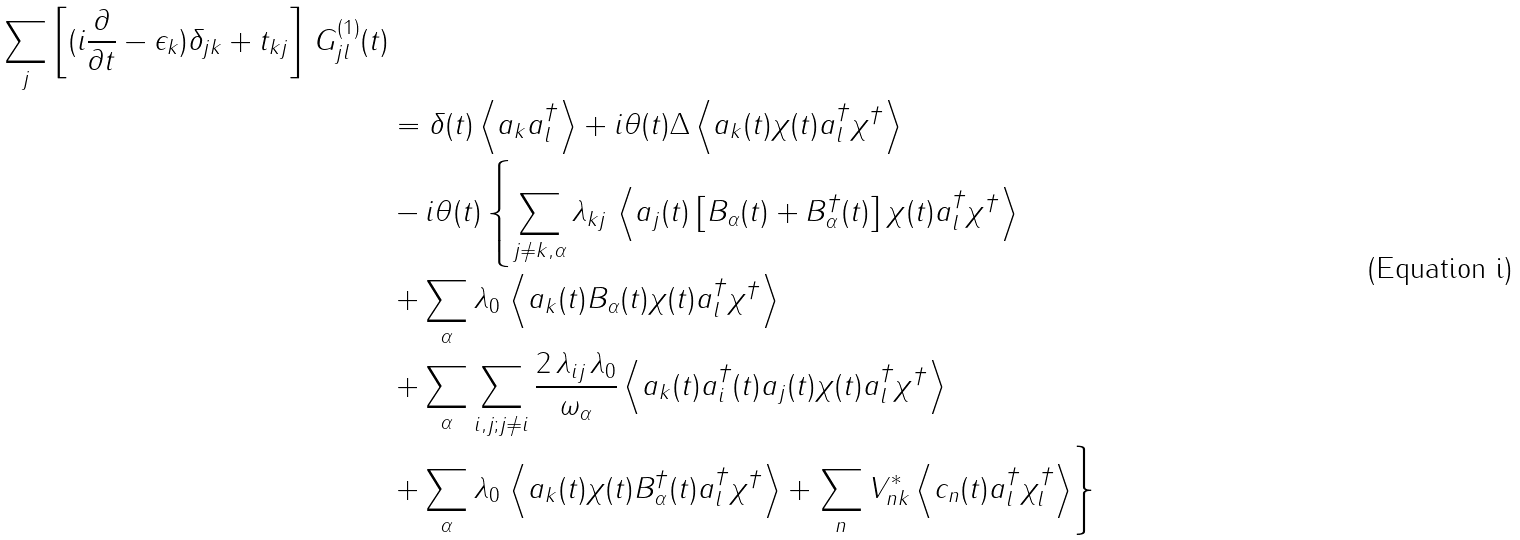Convert formula to latex. <formula><loc_0><loc_0><loc_500><loc_500>{ \sum _ { j } \left [ ( i \frac { \partial } { \partial t } - \epsilon _ { k } ) \delta _ { j k } + t _ { k j } \right ] \, G _ { j l } ^ { ( 1 ) } ( t ) } \\ & = \delta ( t ) \left \langle a _ { k } a _ { l } ^ { \dagger } \right \rangle + i \theta ( t ) \Delta \left \langle a _ { k } ( t ) \chi ( t ) a _ { l } ^ { \dagger } \chi ^ { \dagger } \right \rangle \\ & - i \theta ( t ) \left \{ \sum _ { j \neq k , \alpha } \lambda _ { k j } \, \left \langle a _ { j } ( t ) \left [ B _ { \alpha } ( t ) + B _ { \alpha } ^ { \dagger } ( t ) \right ] \chi ( t ) a _ { l } ^ { \dagger } \chi ^ { \dagger } \right \rangle \right . \\ & + \sum _ { \alpha } \lambda _ { 0 } \, \left \langle a _ { k } ( t ) B _ { \alpha } ( t ) \chi ( t ) a _ { l } ^ { \dagger } \chi ^ { \dagger } \right \rangle \\ & + \sum _ { \alpha } \sum _ { i , j ; j \neq i } \frac { 2 \, \lambda _ { i j } \, \lambda _ { 0 } } { \omega _ { \alpha } } \left \langle a _ { k } ( t ) a _ { i } ^ { \dagger } ( t ) a _ { j } ( t ) \chi ( t ) a _ { l } ^ { \dagger } \chi ^ { \dagger } \right \rangle \\ & + \sum _ { \alpha } \lambda _ { 0 } \, \left \langle a _ { k } ( t ) \chi ( t ) B _ { \alpha } ^ { \dagger } ( t ) a _ { l } ^ { \dagger } \chi ^ { \dagger } \right \rangle + \left . \sum _ { n } V _ { n k } ^ { * } \left \langle c _ { n } ( t ) a _ { l } ^ { \dagger } \chi _ { l } ^ { \dagger } \right \rangle \right \}</formula> 